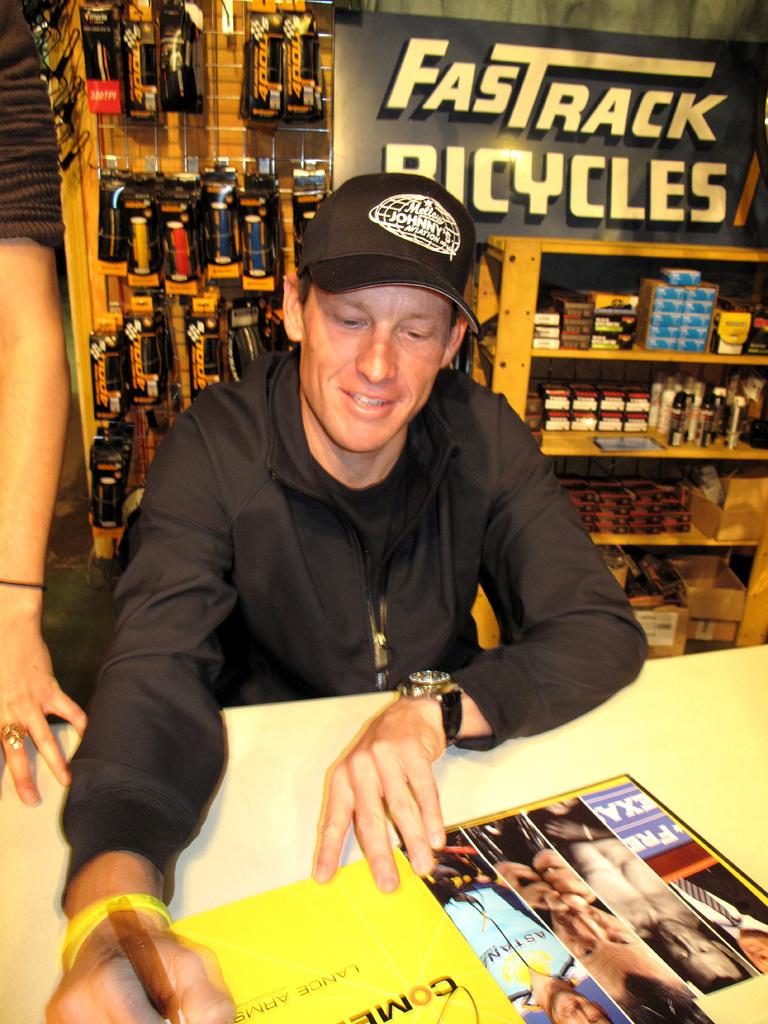What company is advertising in the background?
Offer a terse response. Fastrack bicycles. What is the thr word behind the man on the wall?
Give a very brief answer. Fastrack bicycles. 